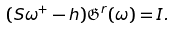Convert formula to latex. <formula><loc_0><loc_0><loc_500><loc_500>( S \omega ^ { + } - h ) \mathfrak G ^ { r } ( \omega ) = I .</formula> 